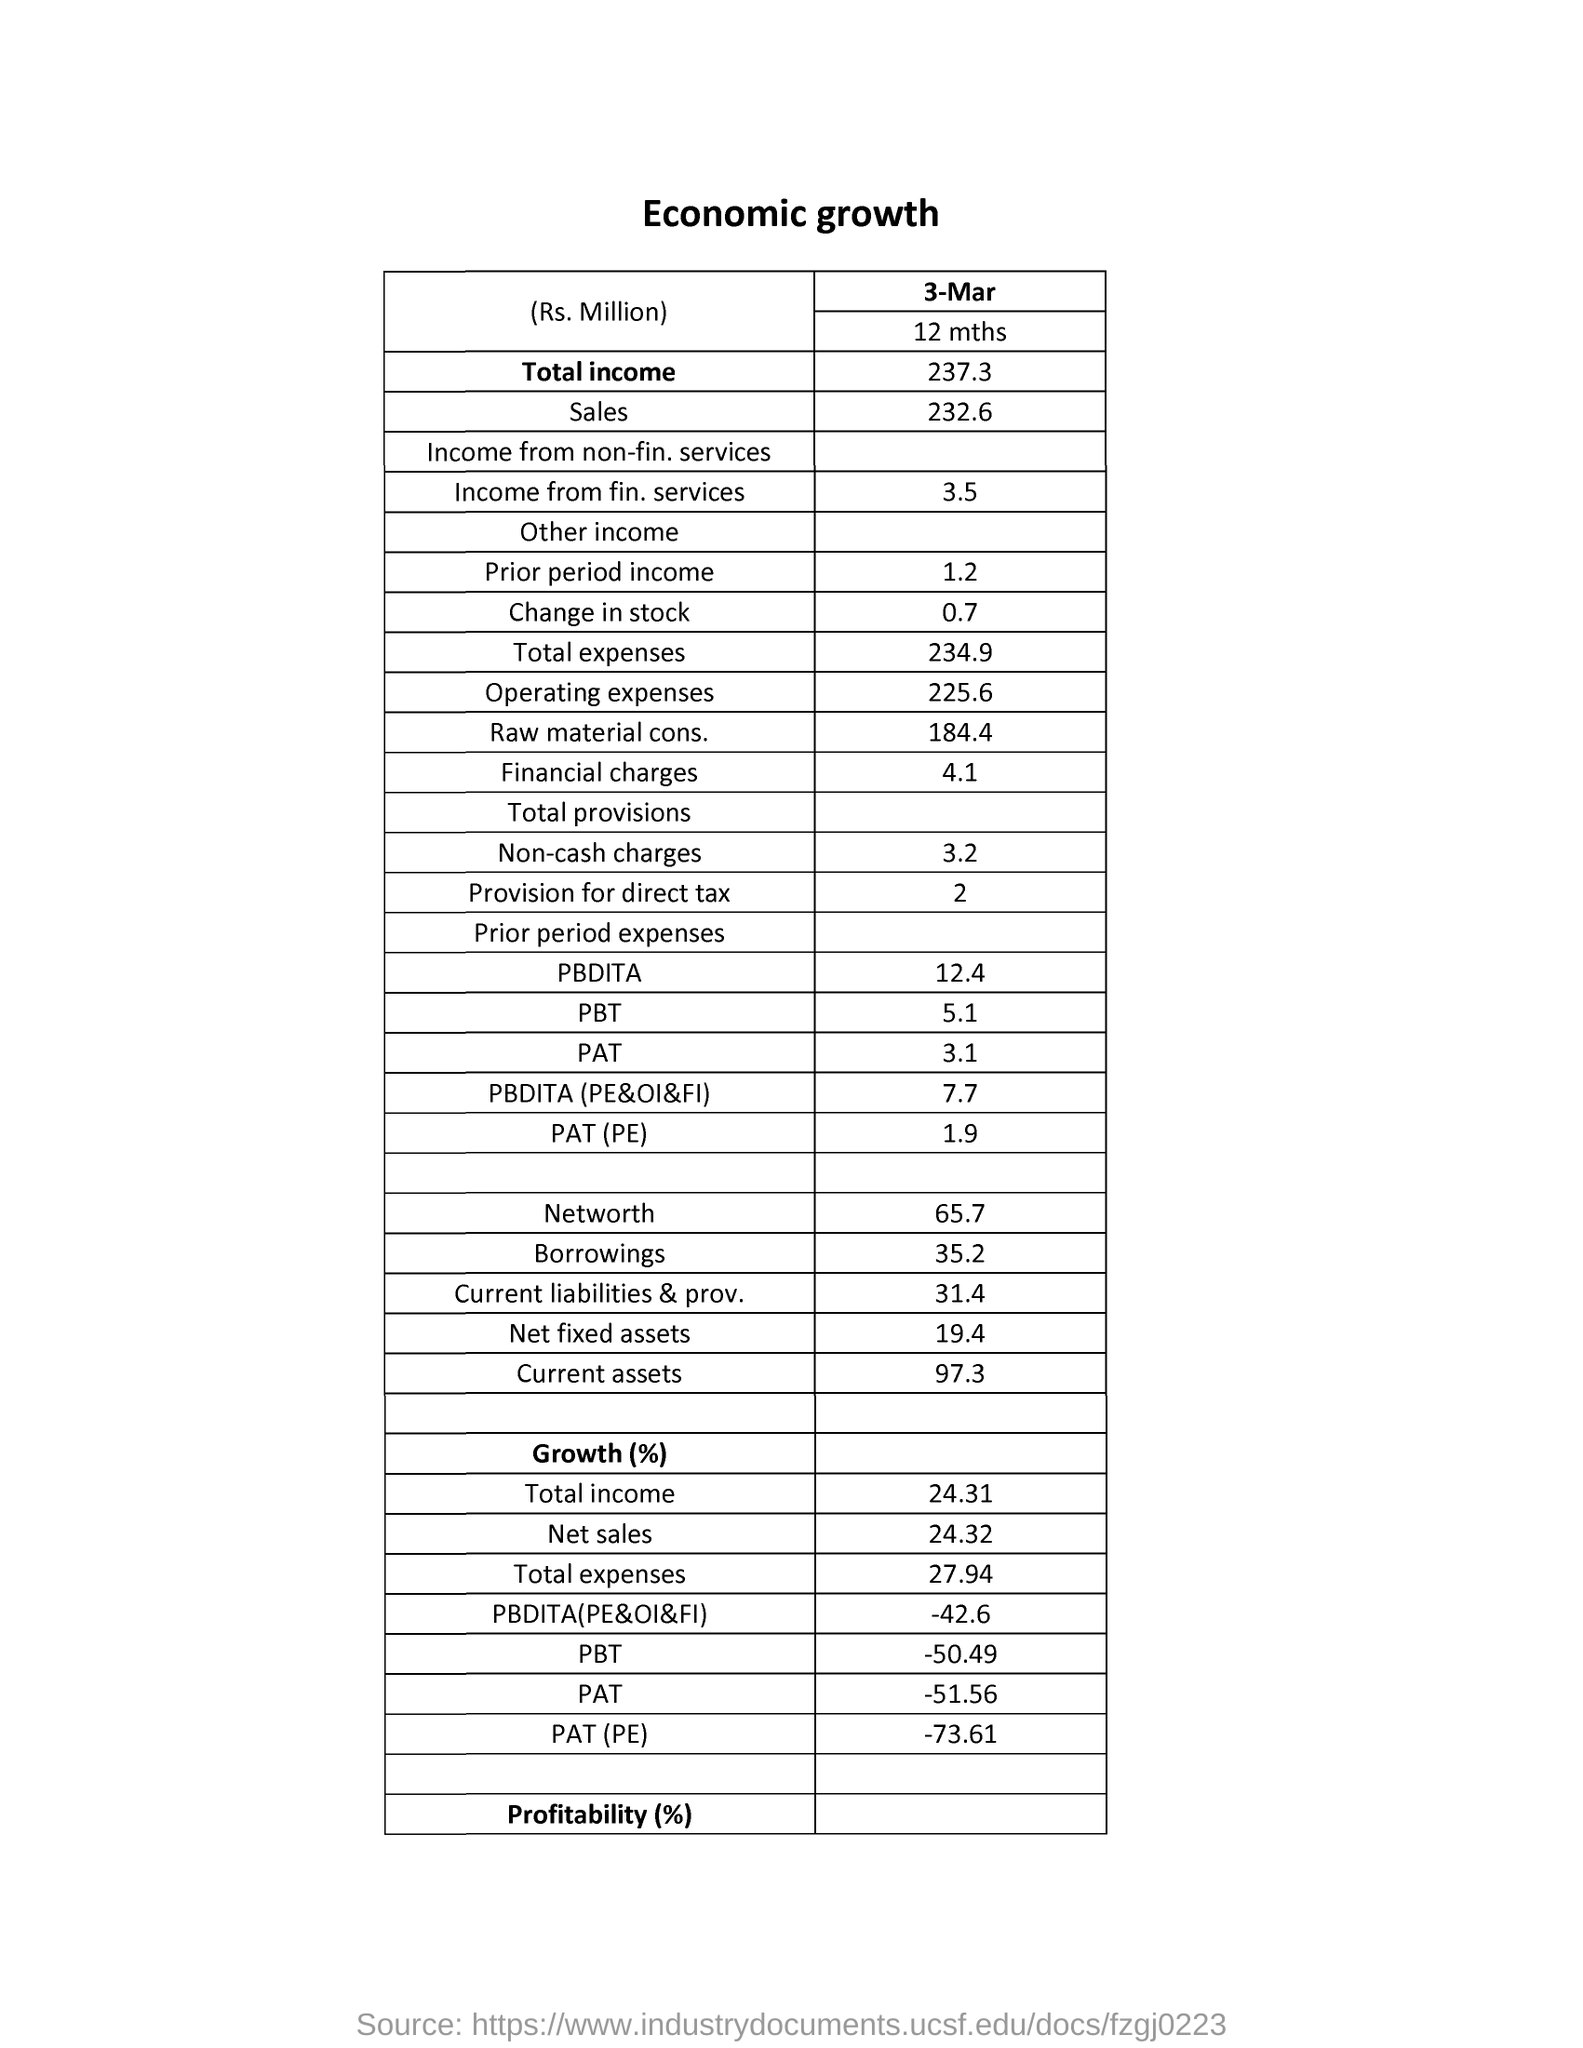What is the name of the table
Give a very brief answer. Economic growth. On which date the economic growth is given
Give a very brief answer. 3-mar. 